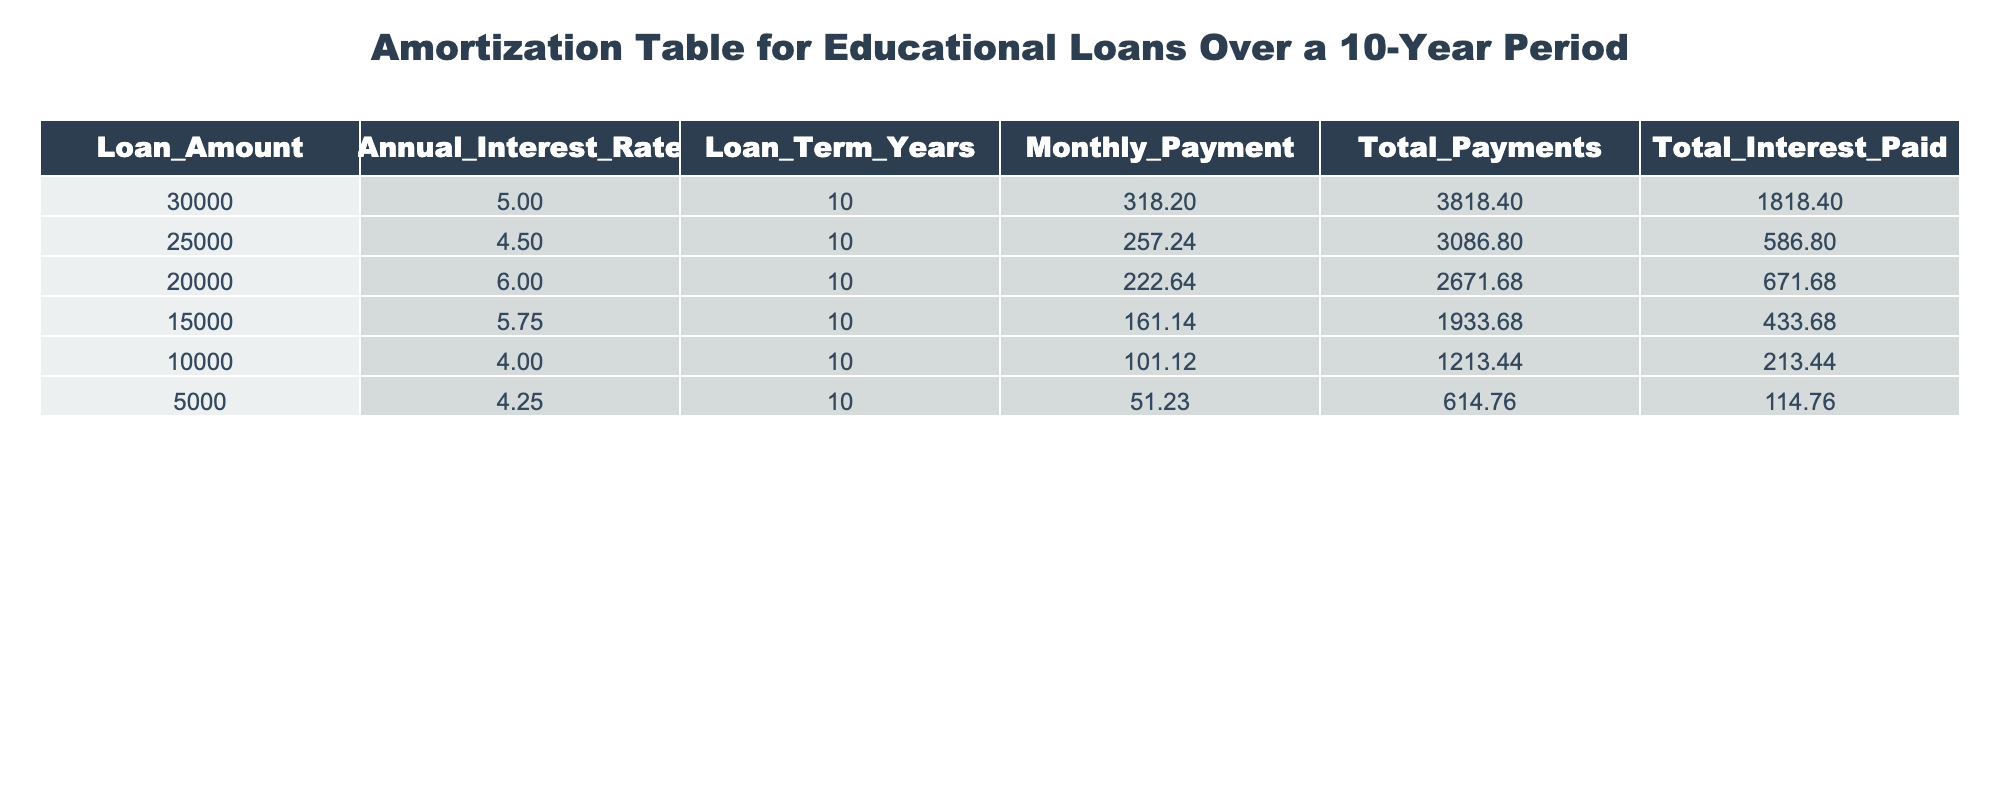What is the monthly payment for a loan amount of 30000? The table shows that for a loan amount of 30000, the Monthly Payment is listed as 318.20.
Answer: 318.20 What is the total interest paid for the loan amount of 15000? According to the table, the Total Interest Paid for a loan amount of 15000 is 433.68.
Answer: 433.68 Which loan amount has the highest total payments? By examining the Total Payments column, we see that the loan amount of 30000 has the highest total payments of 3818.40.
Answer: 30000 What is the average total interest paid across all loans listed? The Total Interest Paid values are 1818.40, 586.80, 671.68, 433.68, 213.44, and 114.76. Summing these gives 4068.76. Dividing by 6 (the number of loans) gives an average of 678.13.
Answer: 678.13 Is the monthly payment for the loan amount of 20000 less than that for the loan amount of 25000? The Monthly Payments for these amounts are 222.64 for 20000 and 257.24 for 25000. Since 222.64 is less than 257.24, the answer is yes.
Answer: Yes What is the difference in total payments between the loan amounts of 5000 and 25000? The Total Payments for the loan amount of 5000 is 614.76, and for 25000, it is 3086.80. Subtracting gives 3086.80 - 614.76 = 2472.04.
Answer: 2472.04 Which loan has the lowest monthly payment, and what is that payment? The loan amount of 5000 has the lowest Monthly Payment of 51.23 according to the table, which can be directly found in the Monthly Payment column.
Answer: 51.23 What is the total amount paid (loan + interest) for the loan of 10000? For a loan amount of 10000, the Total Payments listed is 1213.44. This amount already includes both the loan and interest, so the answer is directly available from the table.
Answer: 1213.44 How does the total interest paid for the loan amount of 30000 compare with that of 20000? The Total Interest Paid for 30000 is 1818.40, while for 20000 it is 671.68. Comparing these values, 1818.40 is greater than 671.68.
Answer: Greater than 